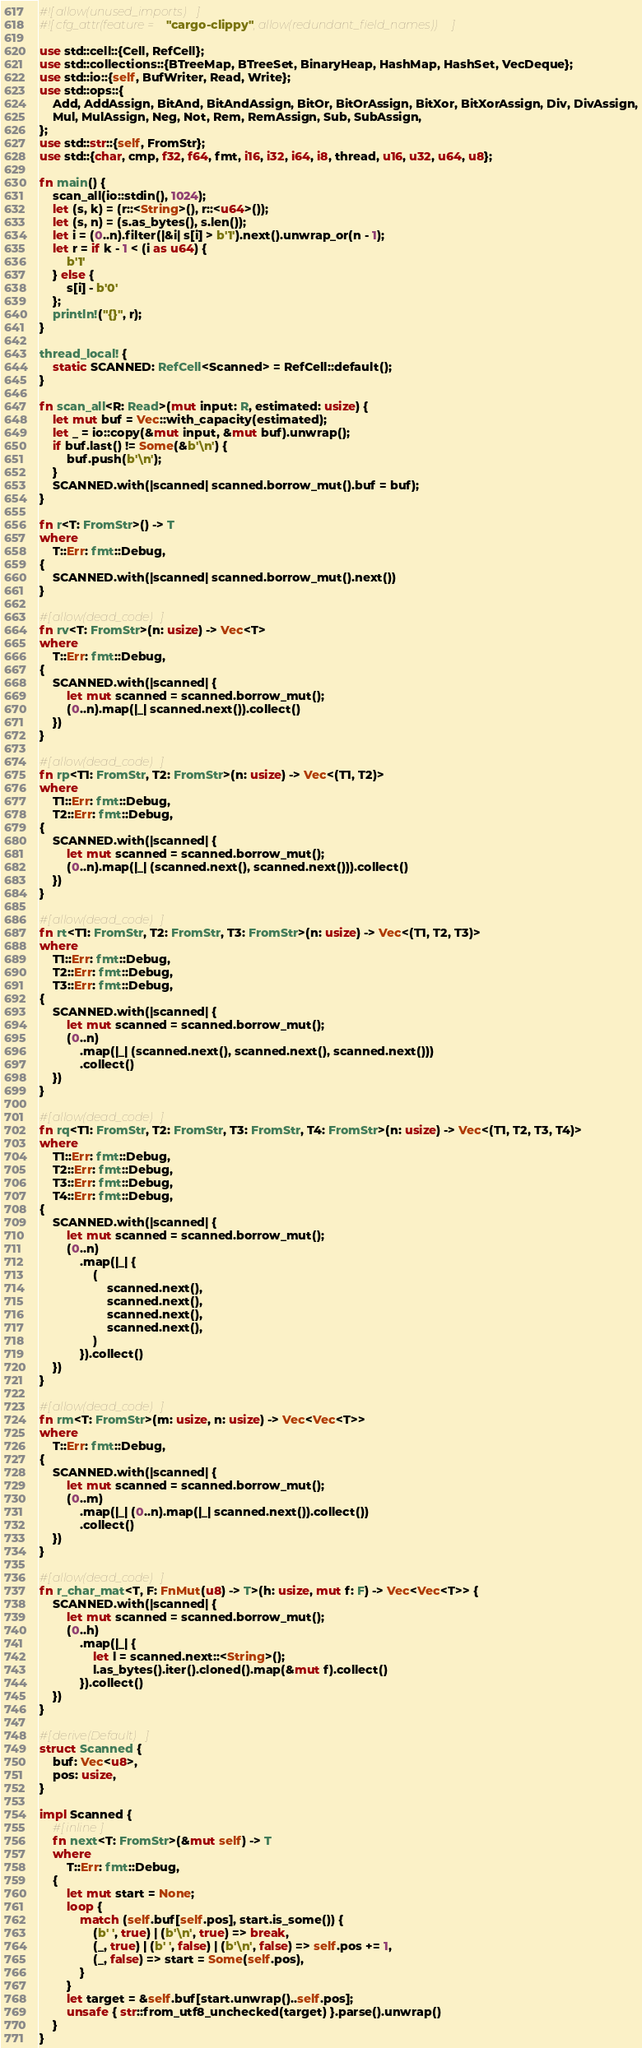Convert code to text. <code><loc_0><loc_0><loc_500><loc_500><_Rust_>#![allow(unused_imports)]
#![cfg_attr(feature = "cargo-clippy", allow(redundant_field_names))]

use std::cell::{Cell, RefCell};
use std::collections::{BTreeMap, BTreeSet, BinaryHeap, HashMap, HashSet, VecDeque};
use std::io::{self, BufWriter, Read, Write};
use std::ops::{
    Add, AddAssign, BitAnd, BitAndAssign, BitOr, BitOrAssign, BitXor, BitXorAssign, Div, DivAssign,
    Mul, MulAssign, Neg, Not, Rem, RemAssign, Sub, SubAssign,
};
use std::str::{self, FromStr};
use std::{char, cmp, f32, f64, fmt, i16, i32, i64, i8, thread, u16, u32, u64, u8};

fn main() {
    scan_all(io::stdin(), 1024);
    let (s, k) = (r::<String>(), r::<u64>());
    let (s, n) = (s.as_bytes(), s.len());
    let i = (0..n).filter(|&i| s[i] > b'1').next().unwrap_or(n - 1);
    let r = if k - 1 < (i as u64) {
        b'1'
    } else {
        s[i] - b'0'
    };
    println!("{}", r);
}

thread_local! {
    static SCANNED: RefCell<Scanned> = RefCell::default();
}

fn scan_all<R: Read>(mut input: R, estimated: usize) {
    let mut buf = Vec::with_capacity(estimated);
    let _ = io::copy(&mut input, &mut buf).unwrap();
    if buf.last() != Some(&b'\n') {
        buf.push(b'\n');
    }
    SCANNED.with(|scanned| scanned.borrow_mut().buf = buf);
}

fn r<T: FromStr>() -> T
where
    T::Err: fmt::Debug,
{
    SCANNED.with(|scanned| scanned.borrow_mut().next())
}

#[allow(dead_code)]
fn rv<T: FromStr>(n: usize) -> Vec<T>
where
    T::Err: fmt::Debug,
{
    SCANNED.with(|scanned| {
        let mut scanned = scanned.borrow_mut();
        (0..n).map(|_| scanned.next()).collect()
    })
}

#[allow(dead_code)]
fn rp<T1: FromStr, T2: FromStr>(n: usize) -> Vec<(T1, T2)>
where
    T1::Err: fmt::Debug,
    T2::Err: fmt::Debug,
{
    SCANNED.with(|scanned| {
        let mut scanned = scanned.borrow_mut();
        (0..n).map(|_| (scanned.next(), scanned.next())).collect()
    })
}

#[allow(dead_code)]
fn rt<T1: FromStr, T2: FromStr, T3: FromStr>(n: usize) -> Vec<(T1, T2, T3)>
where
    T1::Err: fmt::Debug,
    T2::Err: fmt::Debug,
    T3::Err: fmt::Debug,
{
    SCANNED.with(|scanned| {
        let mut scanned = scanned.borrow_mut();
        (0..n)
            .map(|_| (scanned.next(), scanned.next(), scanned.next()))
            .collect()
    })
}

#[allow(dead_code)]
fn rq<T1: FromStr, T2: FromStr, T3: FromStr, T4: FromStr>(n: usize) -> Vec<(T1, T2, T3, T4)>
where
    T1::Err: fmt::Debug,
    T2::Err: fmt::Debug,
    T3::Err: fmt::Debug,
    T4::Err: fmt::Debug,
{
    SCANNED.with(|scanned| {
        let mut scanned = scanned.borrow_mut();
        (0..n)
            .map(|_| {
                (
                    scanned.next(),
                    scanned.next(),
                    scanned.next(),
                    scanned.next(),
                )
            }).collect()
    })
}

#[allow(dead_code)]
fn rm<T: FromStr>(m: usize, n: usize) -> Vec<Vec<T>>
where
    T::Err: fmt::Debug,
{
    SCANNED.with(|scanned| {
        let mut scanned = scanned.borrow_mut();
        (0..m)
            .map(|_| (0..n).map(|_| scanned.next()).collect())
            .collect()
    })
}

#[allow(dead_code)]
fn r_char_mat<T, F: FnMut(u8) -> T>(h: usize, mut f: F) -> Vec<Vec<T>> {
    SCANNED.with(|scanned| {
        let mut scanned = scanned.borrow_mut();
        (0..h)
            .map(|_| {
                let l = scanned.next::<String>();
                l.as_bytes().iter().cloned().map(&mut f).collect()
            }).collect()
    })
}

#[derive(Default)]
struct Scanned {
    buf: Vec<u8>,
    pos: usize,
}

impl Scanned {
    #[inline]
    fn next<T: FromStr>(&mut self) -> T
    where
        T::Err: fmt::Debug,
    {
        let mut start = None;
        loop {
            match (self.buf[self.pos], start.is_some()) {
                (b' ', true) | (b'\n', true) => break,
                (_, true) | (b' ', false) | (b'\n', false) => self.pos += 1,
                (_, false) => start = Some(self.pos),
            }
        }
        let target = &self.buf[start.unwrap()..self.pos];
        unsafe { str::from_utf8_unchecked(target) }.parse().unwrap()
    }
}
</code> 